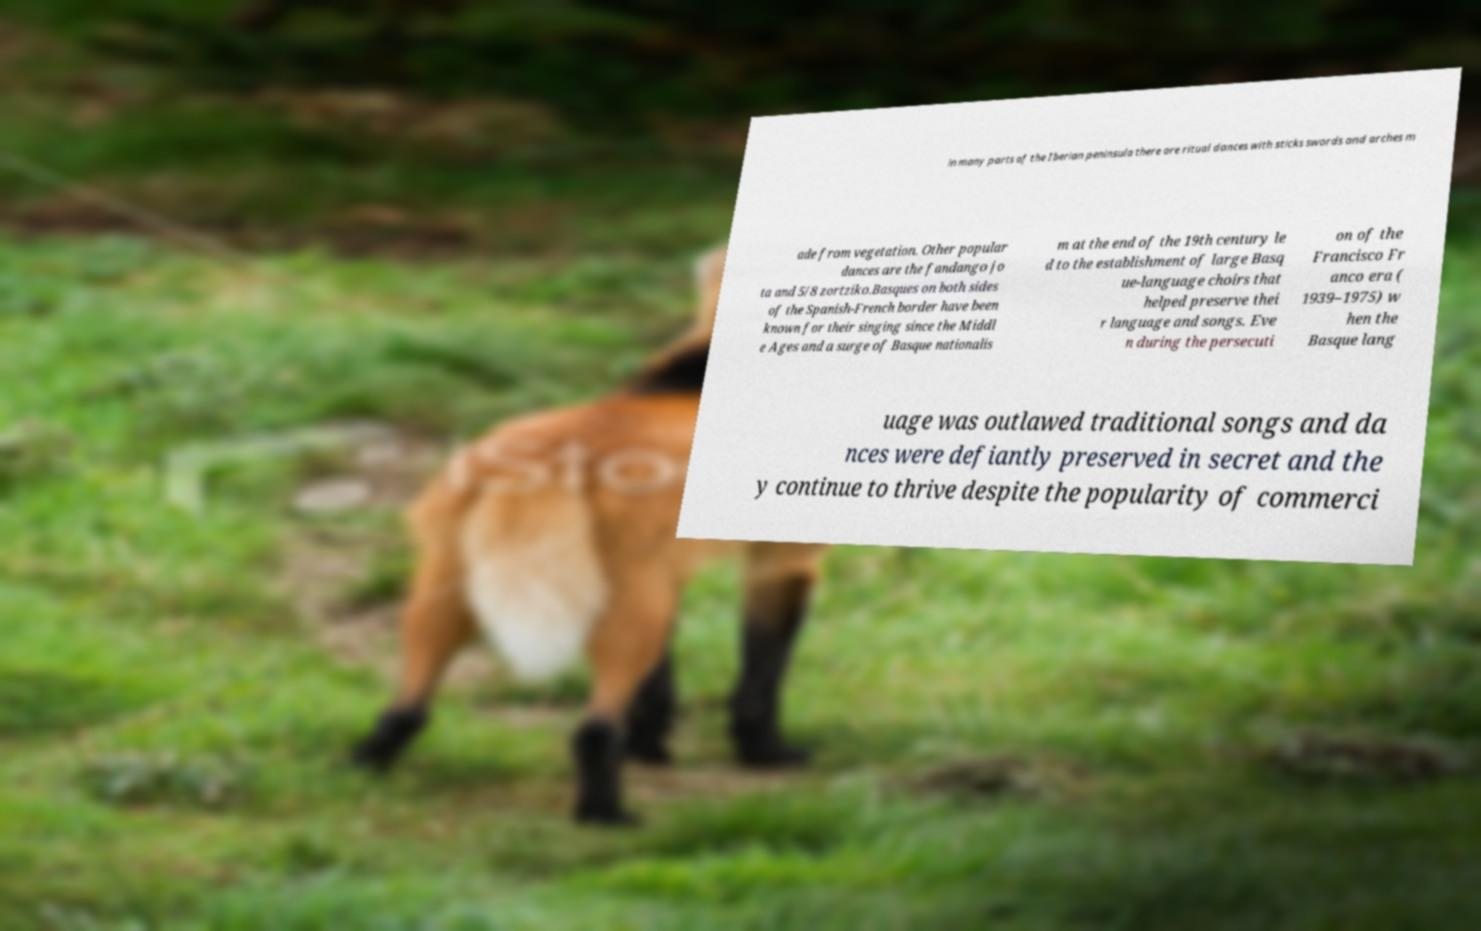Could you assist in decoding the text presented in this image and type it out clearly? in many parts of the Iberian peninsula there are ritual dances with sticks swords and arches m ade from vegetation. Other popular dances are the fandango jo ta and 5/8 zortziko.Basques on both sides of the Spanish-French border have been known for their singing since the Middl e Ages and a surge of Basque nationalis m at the end of the 19th century le d to the establishment of large Basq ue-language choirs that helped preserve thei r language and songs. Eve n during the persecuti on of the Francisco Fr anco era ( 1939–1975) w hen the Basque lang uage was outlawed traditional songs and da nces were defiantly preserved in secret and the y continue to thrive despite the popularity of commerci 